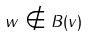Convert formula to latex. <formula><loc_0><loc_0><loc_500><loc_500>w \notin B ( v )</formula> 